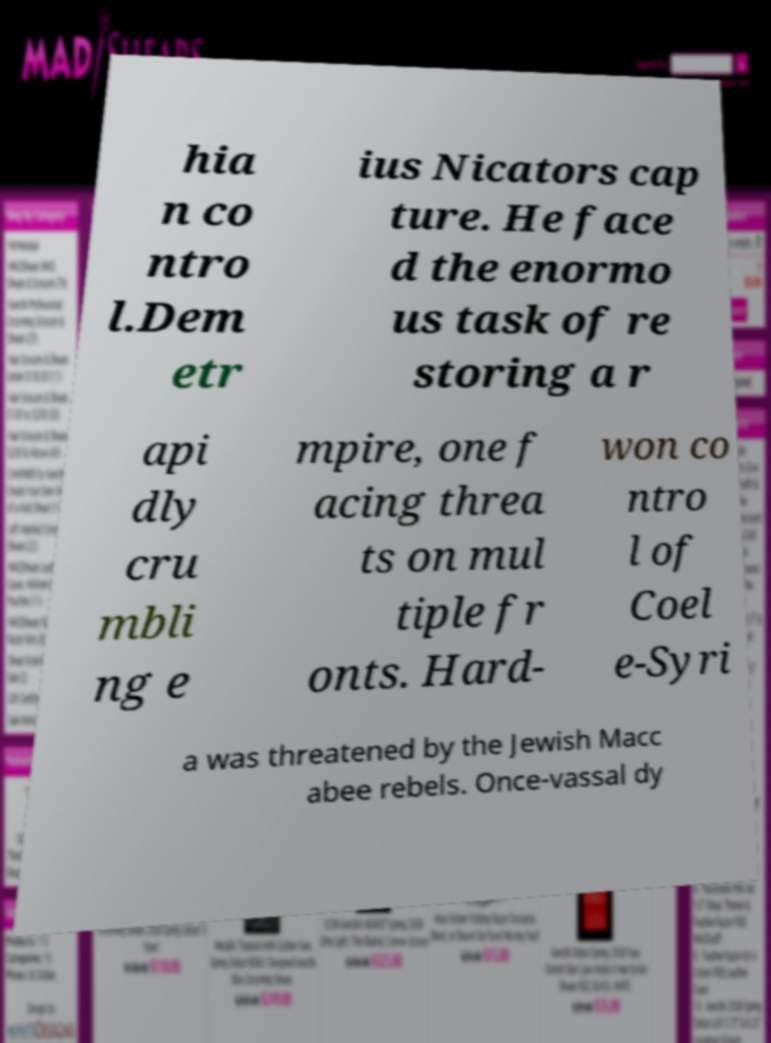Please read and relay the text visible in this image. What does it say? hia n co ntro l.Dem etr ius Nicators cap ture. He face d the enormo us task of re storing a r api dly cru mbli ng e mpire, one f acing threa ts on mul tiple fr onts. Hard- won co ntro l of Coel e-Syri a was threatened by the Jewish Macc abee rebels. Once-vassal dy 